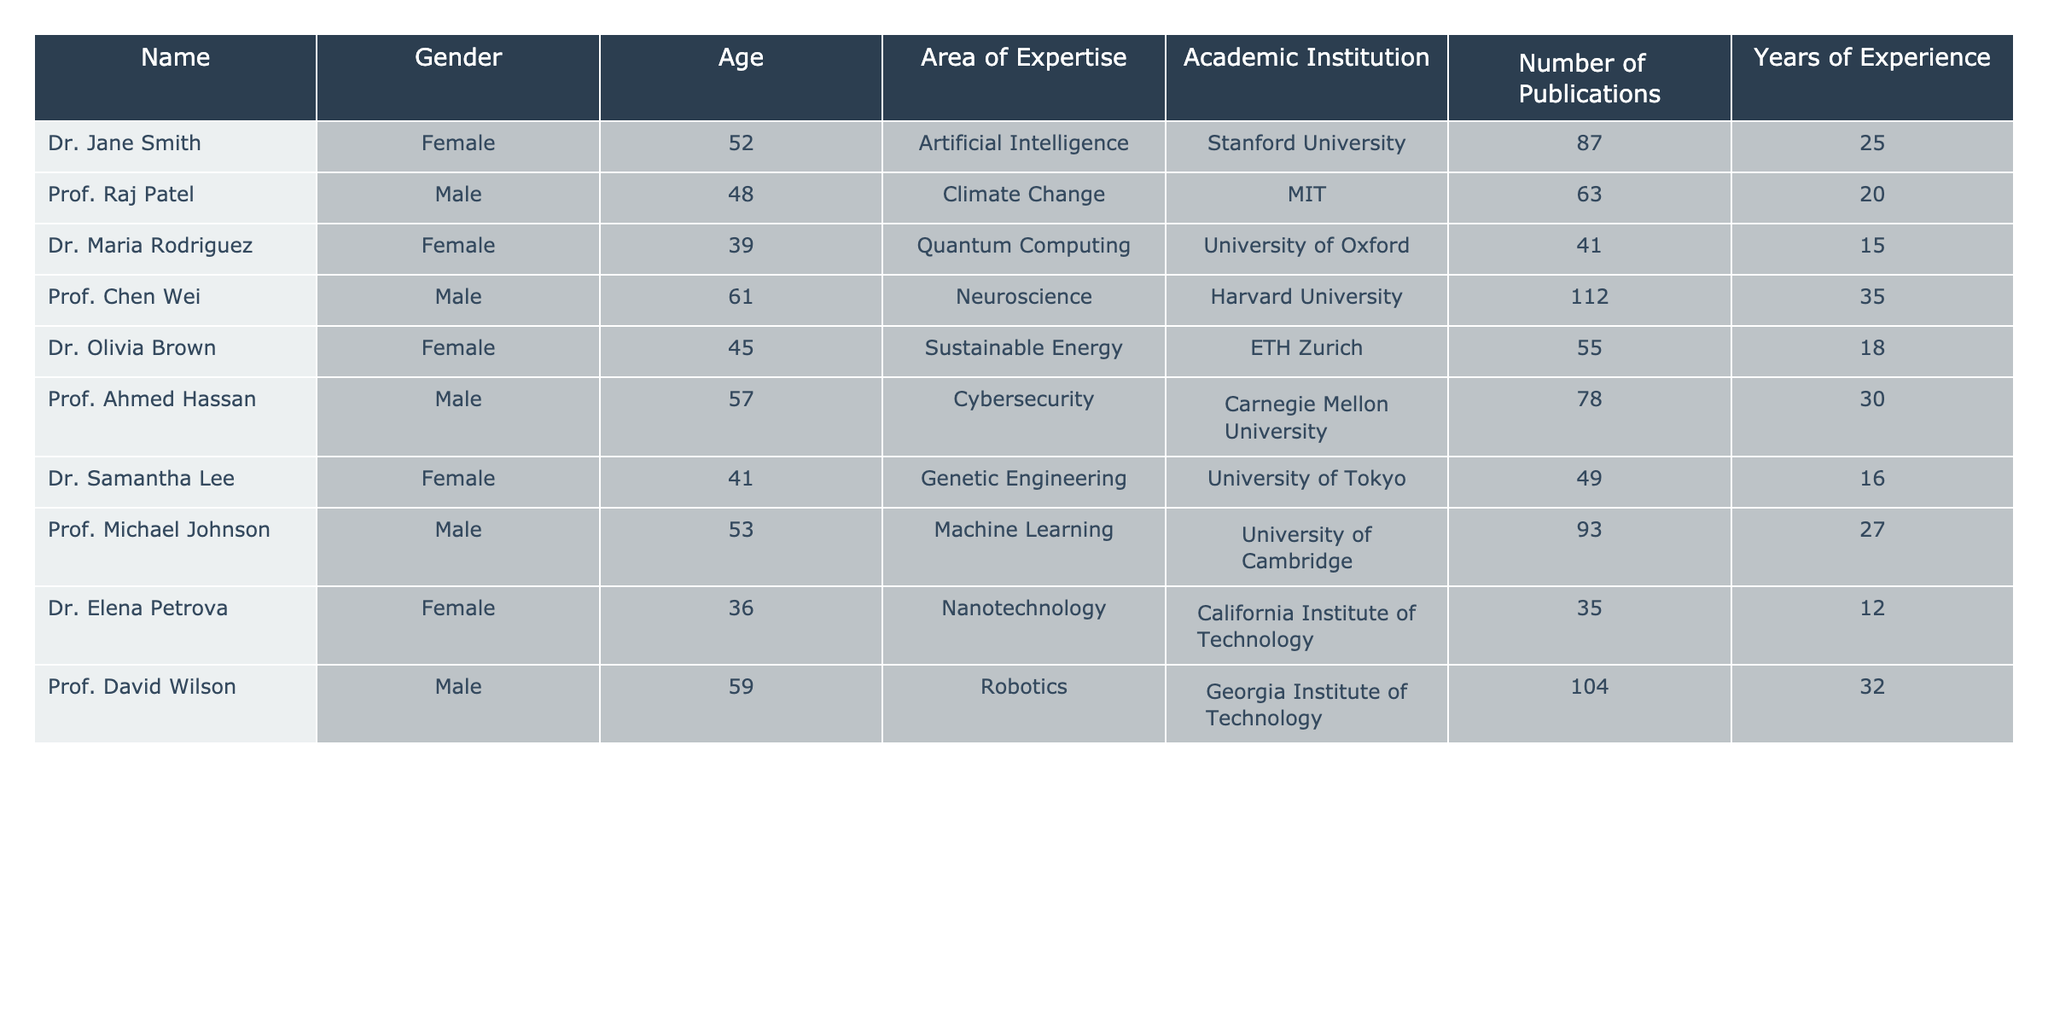What is the total number of publications by all keynote speakers? To find the total number of publications, sum the values in the "Number of Publications" column: 87 + 63 + 41 + 112 + 55 + 78 + 49 + 93 + 35 + 104 =  726.
Answer: 726 Which keynote speaker is the youngest and what is their age? Check the "Age" column for the minimum value. The youngest is Dr. Elena Petrova with an age of 36.
Answer: 36 How many female keynote speakers are there? Count the number of entries in the "Gender" column that are marked as "Female." There are 5 female keynote speakers: Dr. Jane Smith, Dr. Maria Rodriguez, Dr. Olivia Brown, Dr. Samantha Lee, and Dr. Elena Petrova.
Answer: 5 What is the average age of the keynote speakers? To calculate the average, sum the ages (52 + 48 + 39 + 61 + 45 + 57 + 41 + 53 + 36 + 59 =  491) and divide by the number of speakers (10): 491/10 = 49.1.
Answer: 49.1 Is there a keynote speaker from Harvard University? Verify the "Academic Institution" column for "Harvard University." Yes, there is a keynote speaker, Prof. Chen Wei, from Harvard University.
Answer: Yes Which area of expertise has the highest number of publications? Compare the values in the "Number of Publications" column: Prof. Chen Wei, Neuroscience, has the most with 112 publications.
Answer: Neuroscience What is the total years of experience among the male keynote speakers? Sum the "Years of Experience" for male speakers: 20 + 35 + 30 + 27 + 32 = 144.
Answer: 144 What percentage of speakers specialize in Artificial Intelligence and Quantum Computing combined? There are 10 speakers in total. 2 (Dr. Jane Smith and Dr. Maria Rodriguez) specialize in AI and Quantum Computing. The percentage is (2/10)*100 = 20%.
Answer: 20% Which gender has a higher total number of years of experience among the keynote speakers? Calculate the total years of experience for both genders. Female: 25 + 15 + 18 + 16 + 12 = 86, Male: 20 + 35 + 30 + 27 + 32 = 144. Since 144 > 86, males have more experience.
Answer: Male How many different academic institutions are represented among the keynote speakers? List the institutions and count the unique names: Stanford, MIT, University of Oxford, Harvard, ETH Zurich, Carnegie Mellon, University of Tokyo, University of Cambridge, California Institute of Technology, Georgia Tech. This makes for a total of 10.
Answer: 10 